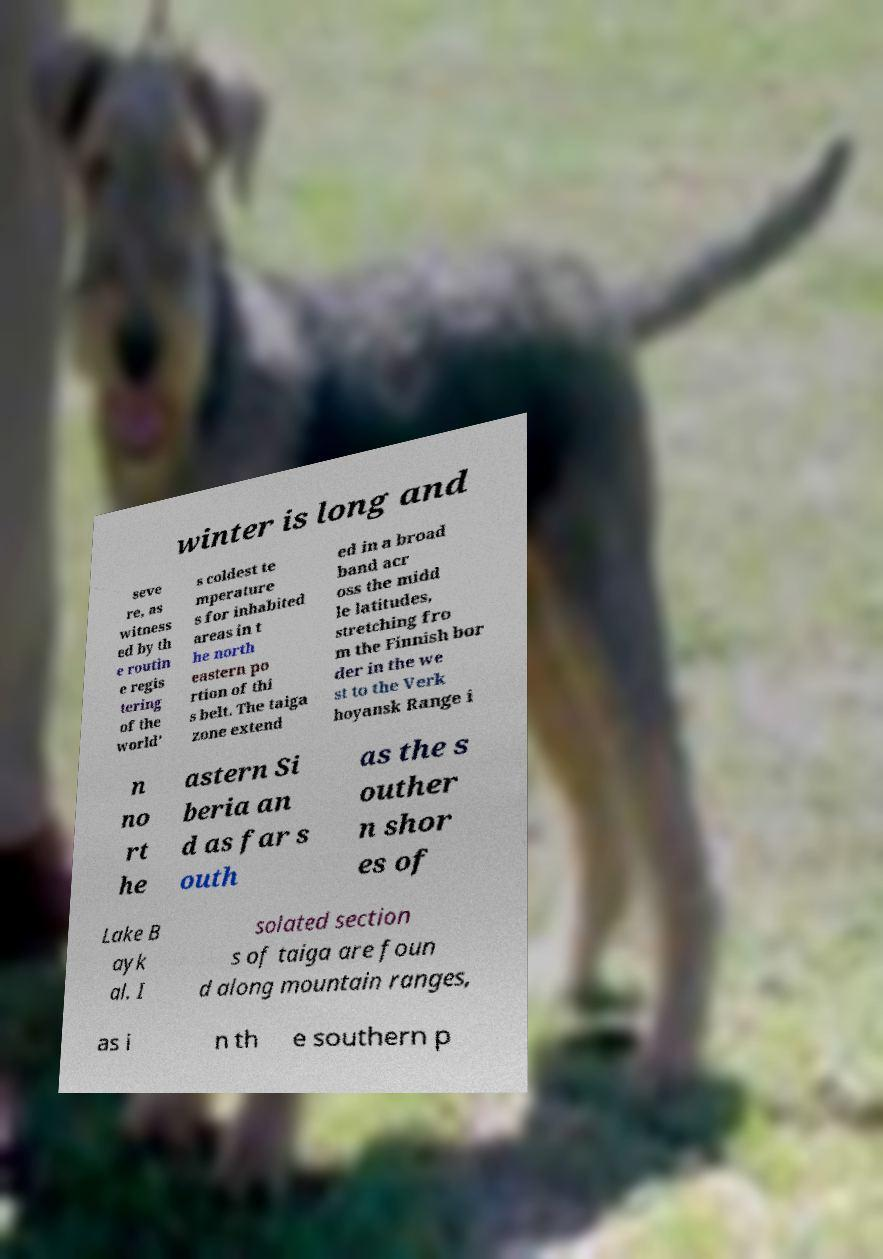For documentation purposes, I need the text within this image transcribed. Could you provide that? winter is long and seve re, as witness ed by th e routin e regis tering of the world' s coldest te mperature s for inhabited areas in t he north eastern po rtion of thi s belt. The taiga zone extend ed in a broad band acr oss the midd le latitudes, stretching fro m the Finnish bor der in the we st to the Verk hoyansk Range i n no rt he astern Si beria an d as far s outh as the s outher n shor es of Lake B ayk al. I solated section s of taiga are foun d along mountain ranges, as i n th e southern p 